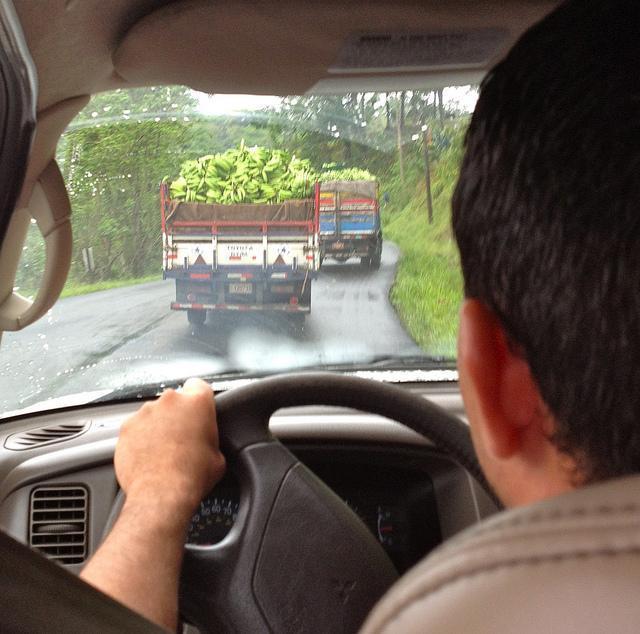What are the chances that at least one banana will fall out of the truck?
Make your selection from the four choices given to correctly answer the question.
Options: High, impossible, very low, low. High. 